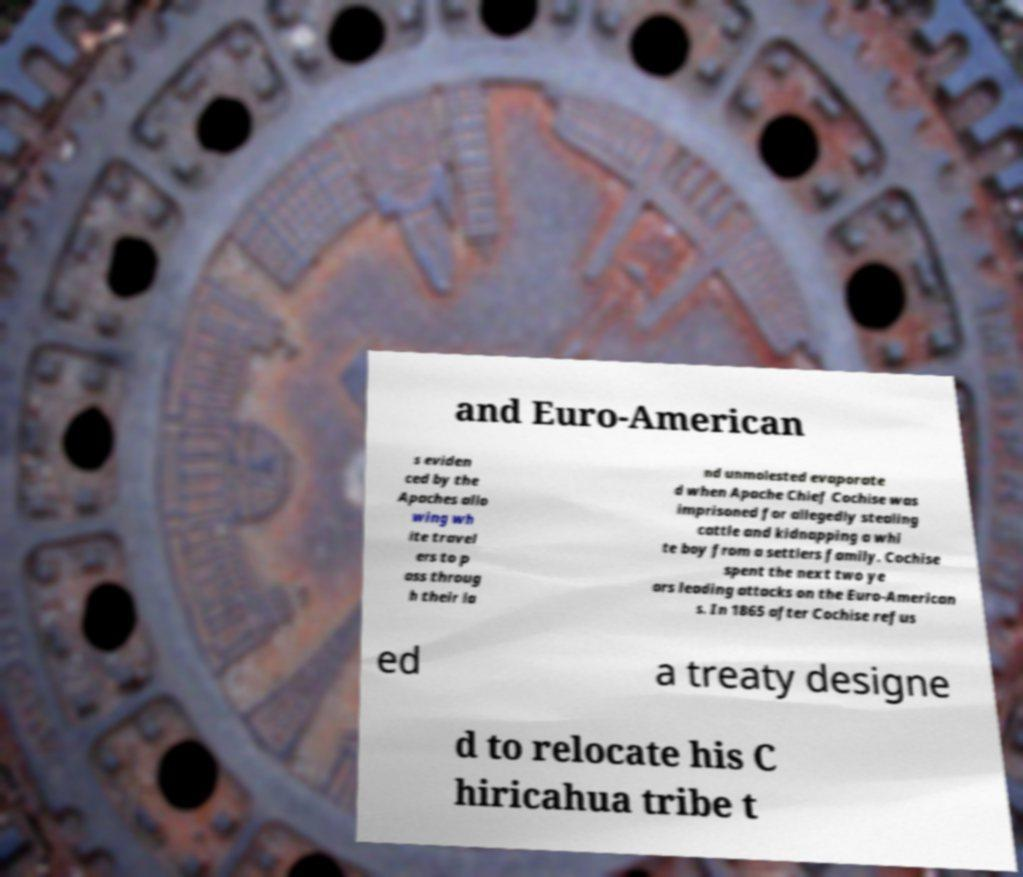Please identify and transcribe the text found in this image. and Euro-American s eviden ced by the Apaches allo wing wh ite travel ers to p ass throug h their la nd unmolested evaporate d when Apache Chief Cochise was imprisoned for allegedly stealing cattle and kidnapping a whi te boy from a settlers family. Cochise spent the next two ye ars leading attacks on the Euro-American s. In 1865 after Cochise refus ed a treaty designe d to relocate his C hiricahua tribe t 